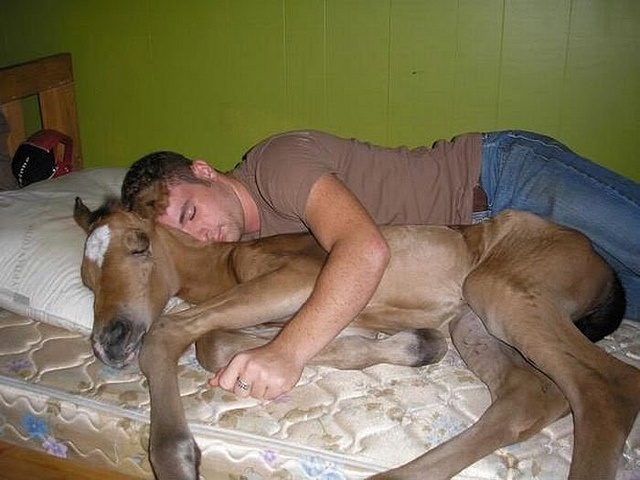Describe the objects in this image and their specific colors. I can see horse in black, gray, and maroon tones, bed in black, darkgray, lightgray, and gray tones, and people in black, gray, tan, and olive tones in this image. 